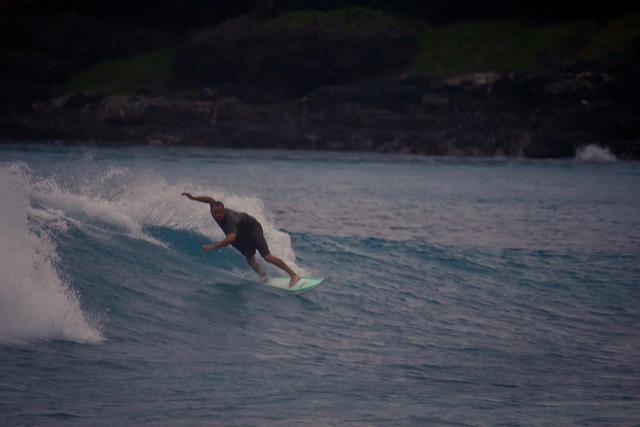How many red bikes are there?
Give a very brief answer. 0. 